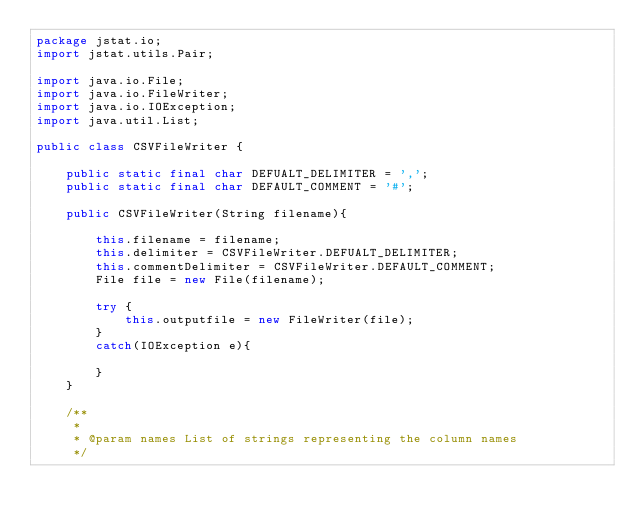<code> <loc_0><loc_0><loc_500><loc_500><_Java_>package jstat.io;
import jstat.utils.Pair;

import java.io.File;
import java.io.FileWriter;
import java.io.IOException;
import java.util.List;

public class CSVFileWriter {

    public static final char DEFUALT_DELIMITER = ',';
    public static final char DEFAULT_COMMENT = '#';

    public CSVFileWriter(String filename){

        this.filename = filename;
        this.delimiter = CSVFileWriter.DEFUALT_DELIMITER;
        this.commentDelimiter = CSVFileWriter.DEFAULT_COMMENT;
        File file = new File(filename);

        try {
            this.outputfile = new FileWriter(file);
        }
        catch(IOException e){

        }
    }

    /**
     *
     * @param names List of strings representing the column names
     */</code> 